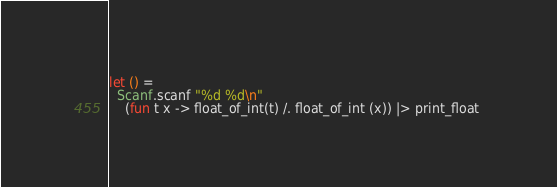<code> <loc_0><loc_0><loc_500><loc_500><_OCaml_>let () =
  Scanf.scanf "%d %d\n"
    (fun t x -> float_of_int(t) /. float_of_int (x)) |> print_float </code> 